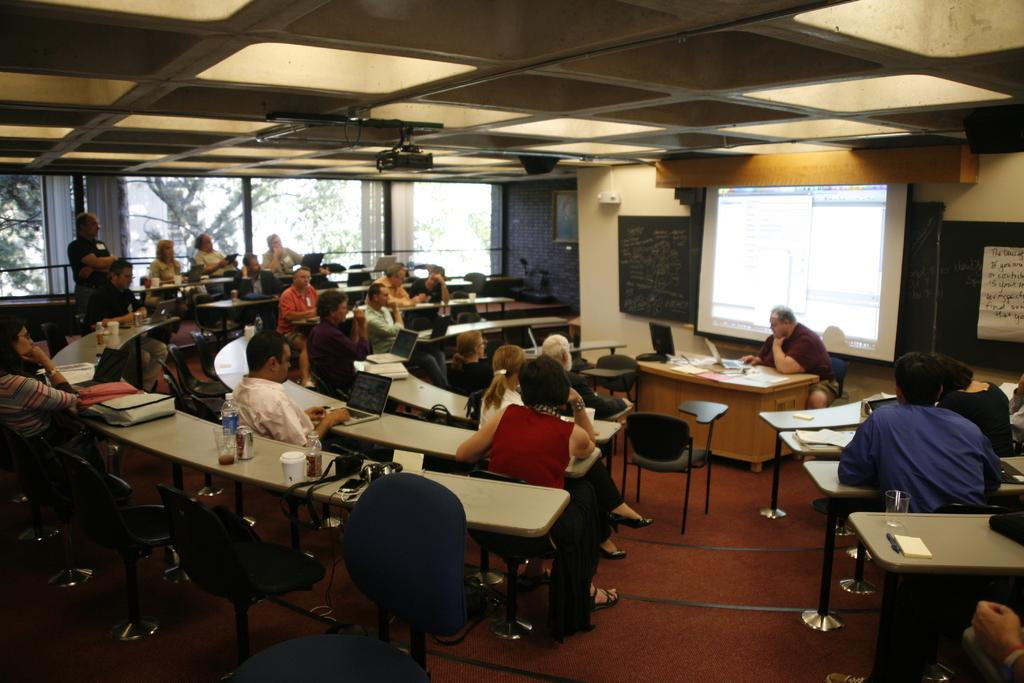What are the people in the image doing? The people in the image are sitting on chairs. What can be seen in the background of the image? There is a projector screen in the background of the image. What is present on the tables in the image? There are items on the tables in the image. What decision did the people make during the basketball game in the image? There is no basketball game or decision-making process depicted in the image; it only shows people sitting on chairs and a projector screen in the background. 